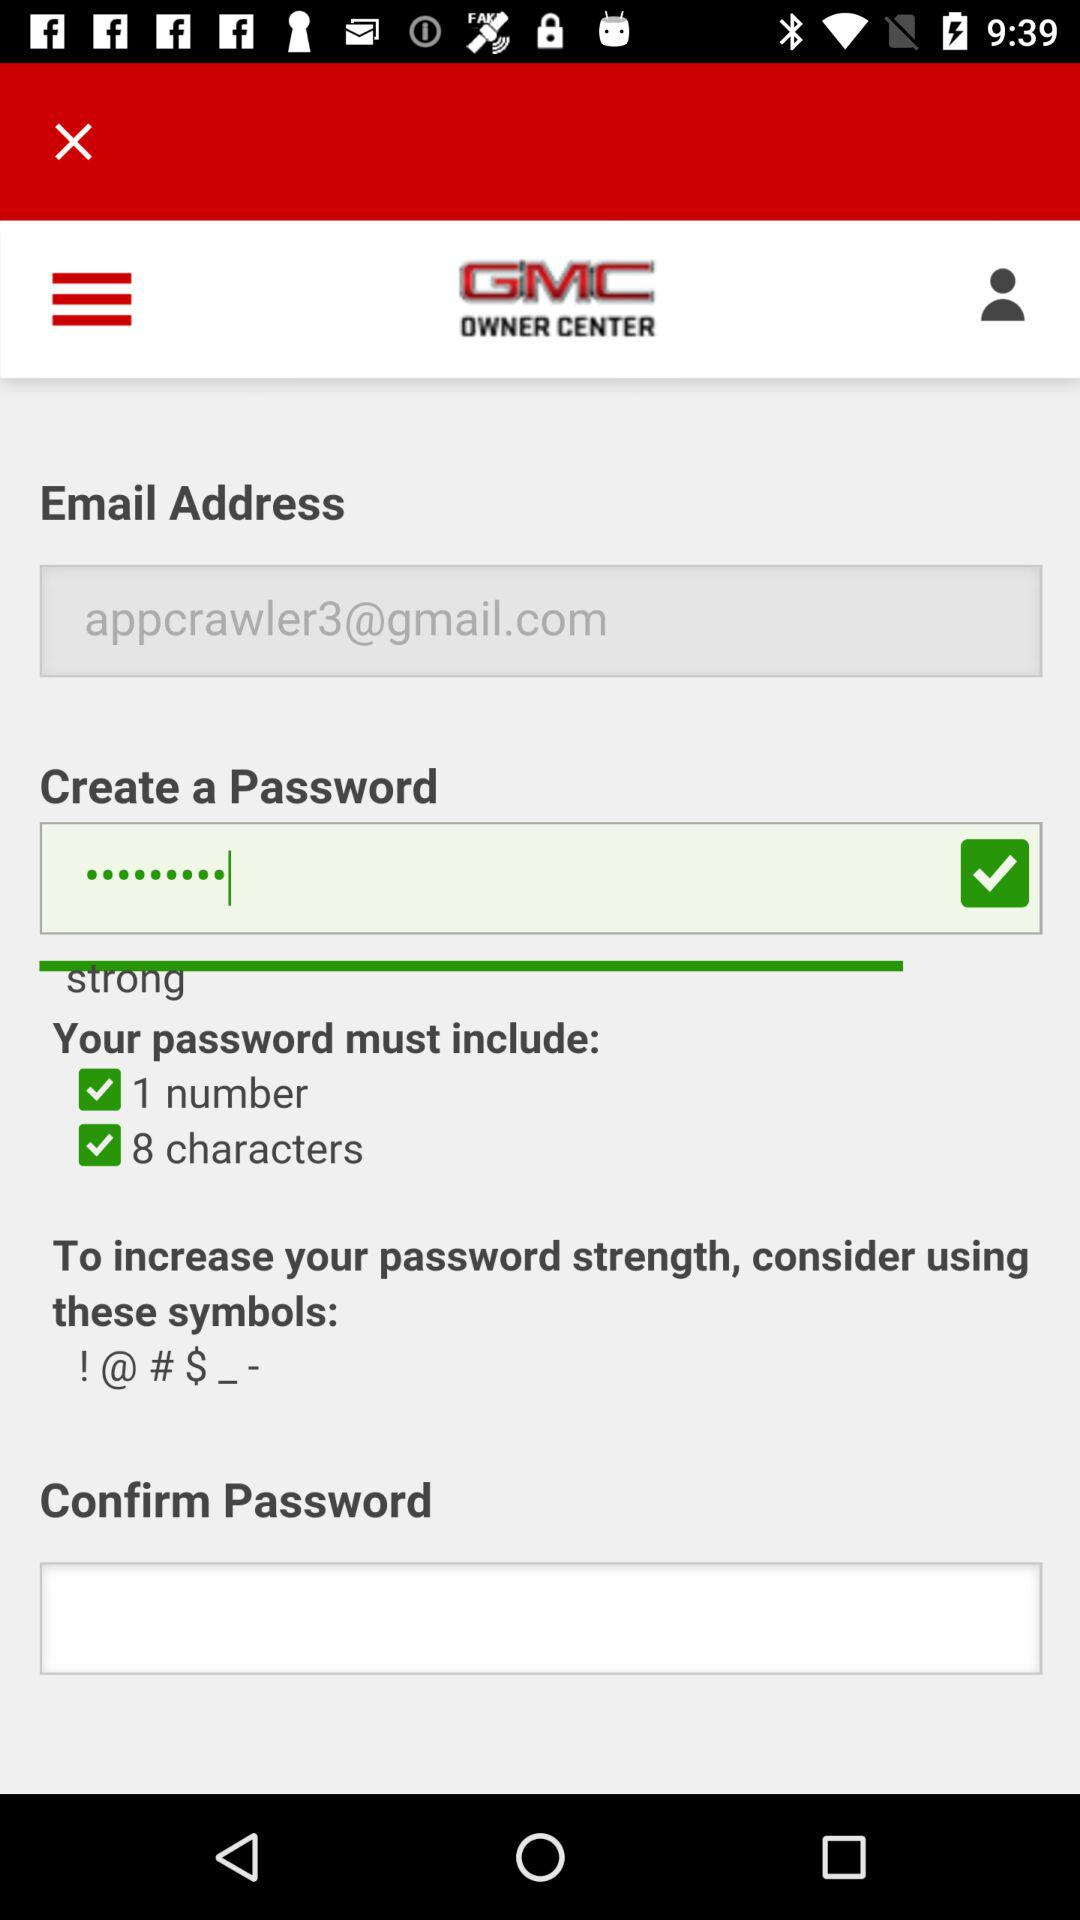How many symbols are required to create a password?
When the provided information is insufficient, respond with <no answer>. <no answer> 